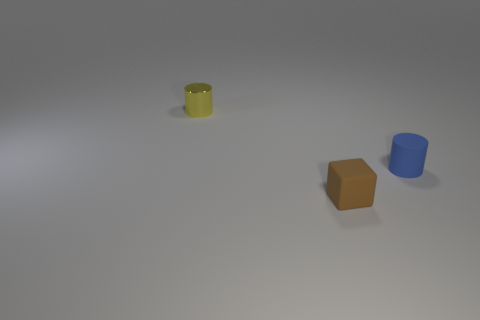Are there any other things that have the same material as the tiny yellow cylinder?
Offer a very short reply. No. There is a small matte object to the left of the rubber object on the right side of the brown block; are there any matte things that are right of it?
Provide a succinct answer. Yes. What number of yellow things are the same size as the matte cube?
Keep it short and to the point. 1. There is a thing that is both on the left side of the small rubber cylinder and behind the tiny brown rubber object; what is its shape?
Your response must be concise. Cylinder. Is there a small matte thing that has the same color as the metal object?
Make the answer very short. No. Are any small matte objects visible?
Provide a short and direct response. Yes. There is a small thing that is behind the rubber cylinder; what is its color?
Provide a short and direct response. Yellow. How big is the thing that is both behind the small brown matte block and on the right side of the small metal object?
Offer a terse response. Small. Are there any small yellow objects that have the same material as the brown block?
Offer a terse response. No. The brown rubber object has what shape?
Your answer should be compact. Cube. 